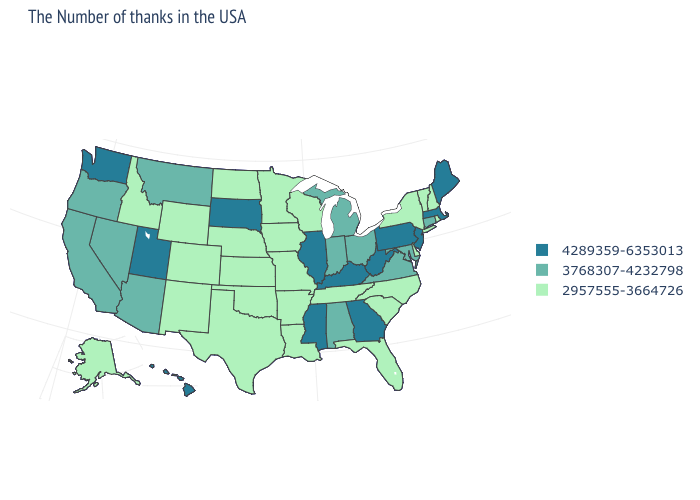Which states have the highest value in the USA?
Quick response, please. Maine, Massachusetts, New Jersey, Pennsylvania, West Virginia, Georgia, Kentucky, Illinois, Mississippi, South Dakota, Utah, Washington, Hawaii. What is the lowest value in the USA?
Short answer required. 2957555-3664726. What is the value of New Mexico?
Quick response, please. 2957555-3664726. Which states hav the highest value in the West?
Quick response, please. Utah, Washington, Hawaii. Does Louisiana have the lowest value in the USA?
Keep it brief. Yes. What is the lowest value in the MidWest?
Keep it brief. 2957555-3664726. Among the states that border New Mexico , does Utah have the highest value?
Answer briefly. Yes. How many symbols are there in the legend?
Answer briefly. 3. What is the lowest value in the USA?
Give a very brief answer. 2957555-3664726. What is the lowest value in states that border New Mexico?
Answer briefly. 2957555-3664726. Does Utah have a lower value than Delaware?
Short answer required. No. Which states have the lowest value in the USA?
Write a very short answer. Rhode Island, New Hampshire, Vermont, New York, Delaware, North Carolina, South Carolina, Florida, Tennessee, Wisconsin, Louisiana, Missouri, Arkansas, Minnesota, Iowa, Kansas, Nebraska, Oklahoma, Texas, North Dakota, Wyoming, Colorado, New Mexico, Idaho, Alaska. Among the states that border New Hampshire , does Maine have the highest value?
Quick response, please. Yes. Name the states that have a value in the range 2957555-3664726?
Short answer required. Rhode Island, New Hampshire, Vermont, New York, Delaware, North Carolina, South Carolina, Florida, Tennessee, Wisconsin, Louisiana, Missouri, Arkansas, Minnesota, Iowa, Kansas, Nebraska, Oklahoma, Texas, North Dakota, Wyoming, Colorado, New Mexico, Idaho, Alaska. 